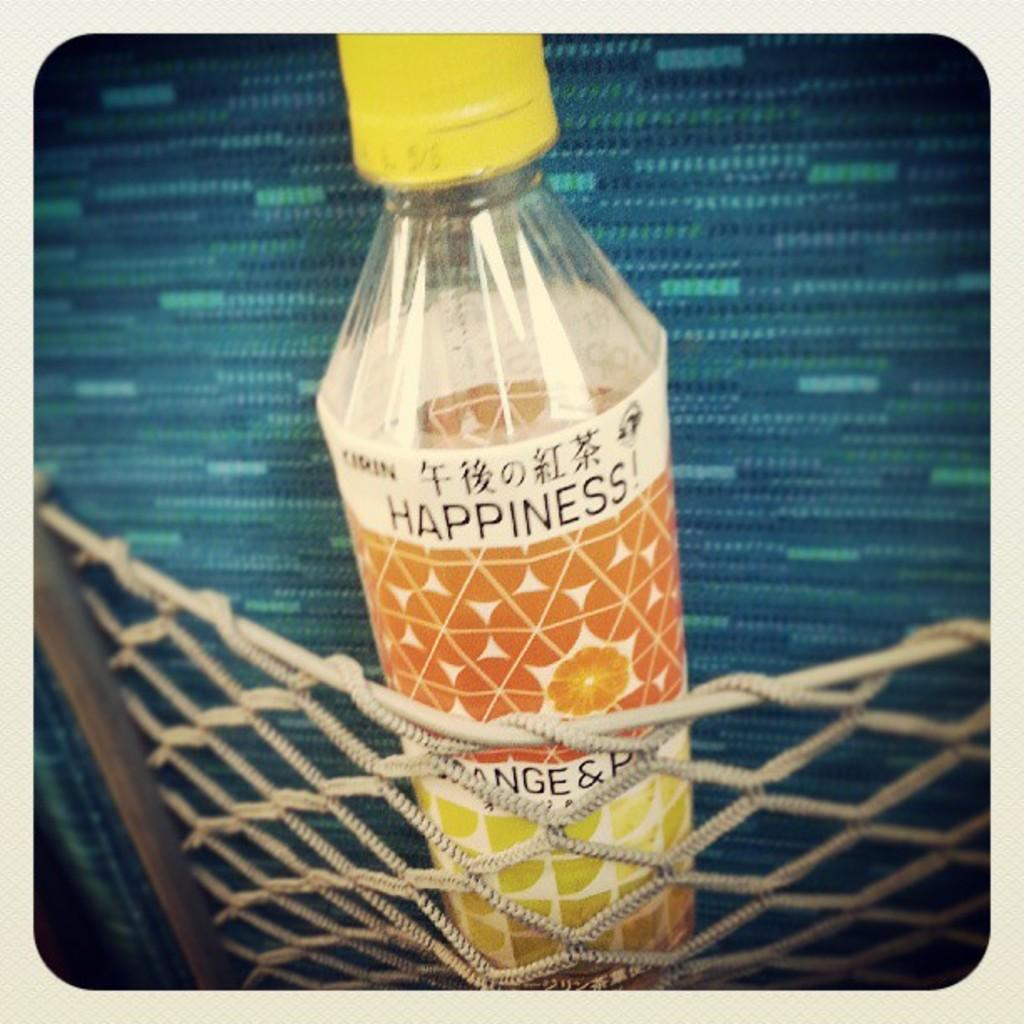<image>
Create a compact narrative representing the image presented. A bottle of happiness drink sits in a net pocket. 